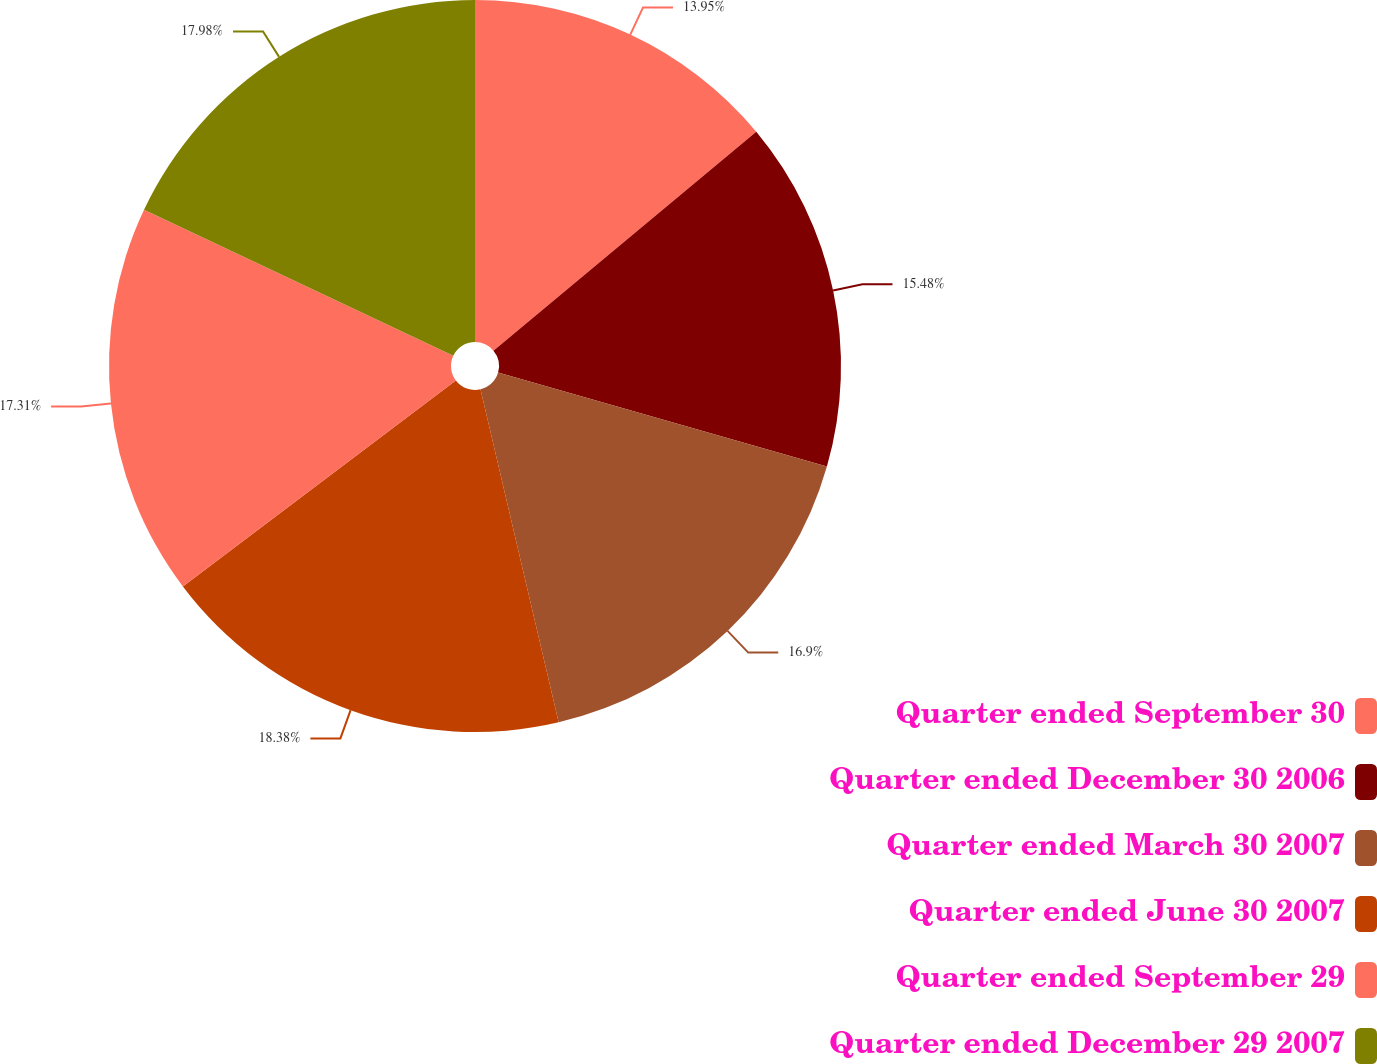<chart> <loc_0><loc_0><loc_500><loc_500><pie_chart><fcel>Quarter ended September 30<fcel>Quarter ended December 30 2006<fcel>Quarter ended March 30 2007<fcel>Quarter ended June 30 2007<fcel>Quarter ended September 29<fcel>Quarter ended December 29 2007<nl><fcel>13.95%<fcel>15.48%<fcel>16.9%<fcel>18.38%<fcel>17.31%<fcel>17.98%<nl></chart> 